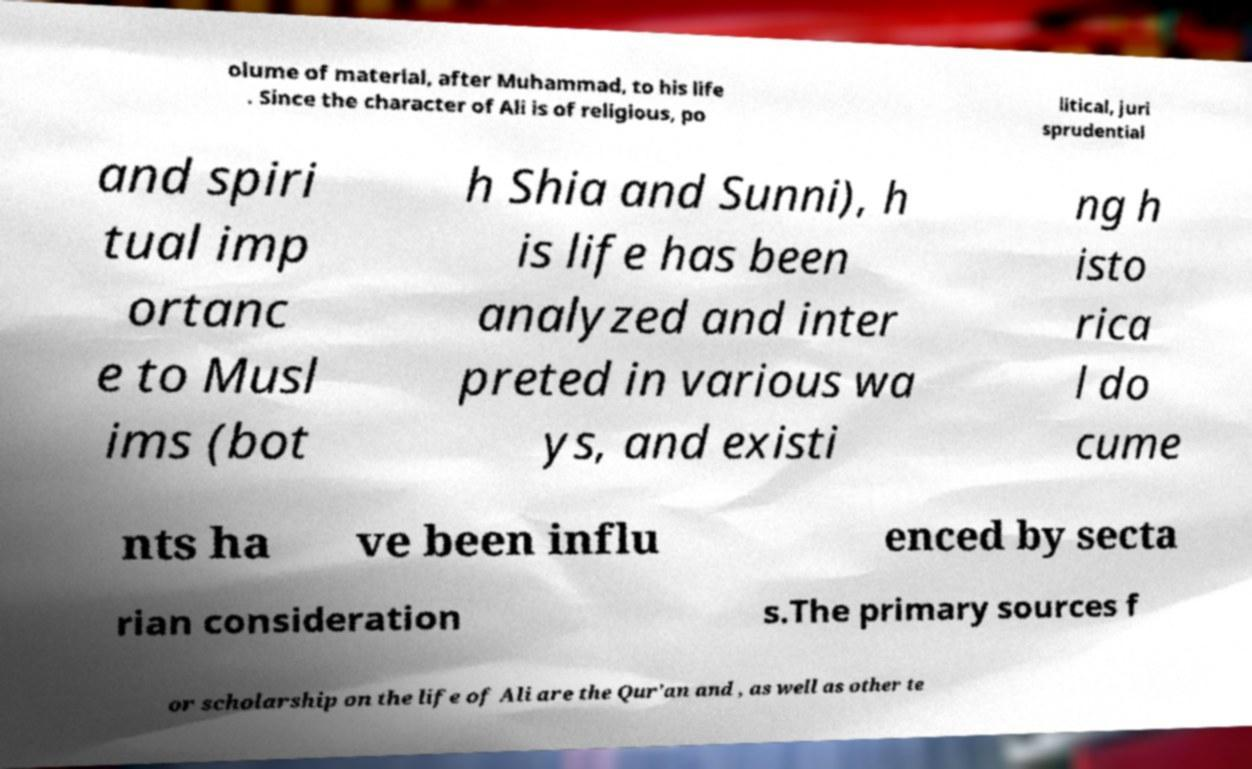For documentation purposes, I need the text within this image transcribed. Could you provide that? olume of material, after Muhammad, to his life . Since the character of Ali is of religious, po litical, juri sprudential and spiri tual imp ortanc e to Musl ims (bot h Shia and Sunni), h is life has been analyzed and inter preted in various wa ys, and existi ng h isto rica l do cume nts ha ve been influ enced by secta rian consideration s.The primary sources f or scholarship on the life of Ali are the Qur'an and , as well as other te 